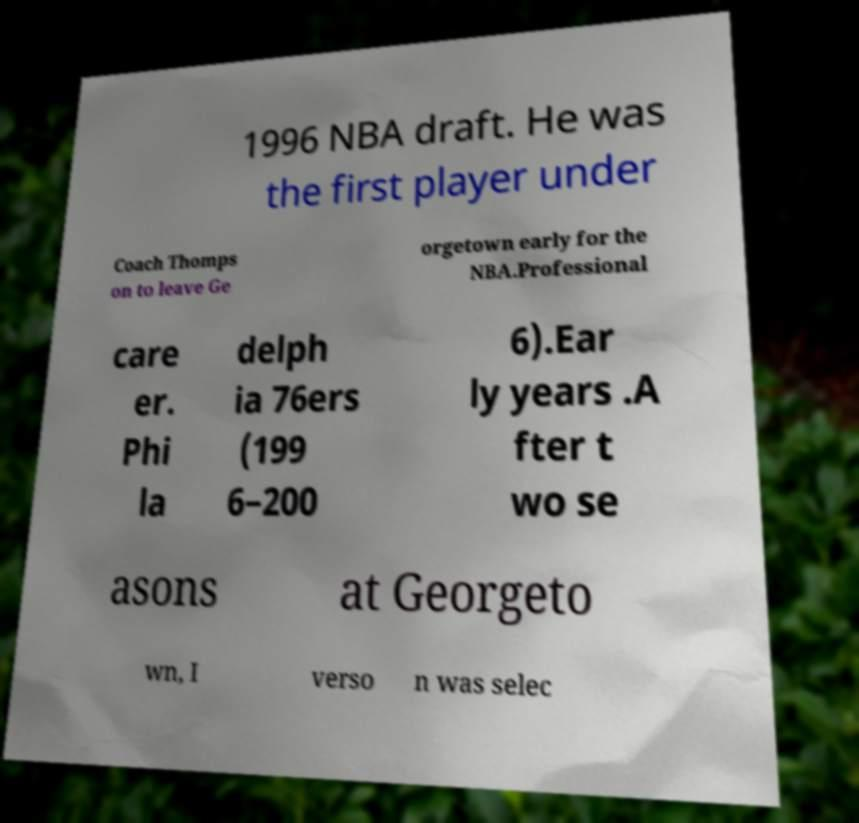Could you extract and type out the text from this image? 1996 NBA draft. He was the first player under Coach Thomps on to leave Ge orgetown early for the NBA.Professional care er. Phi la delph ia 76ers (199 6–200 6).Ear ly years .A fter t wo se asons at Georgeto wn, I verso n was selec 